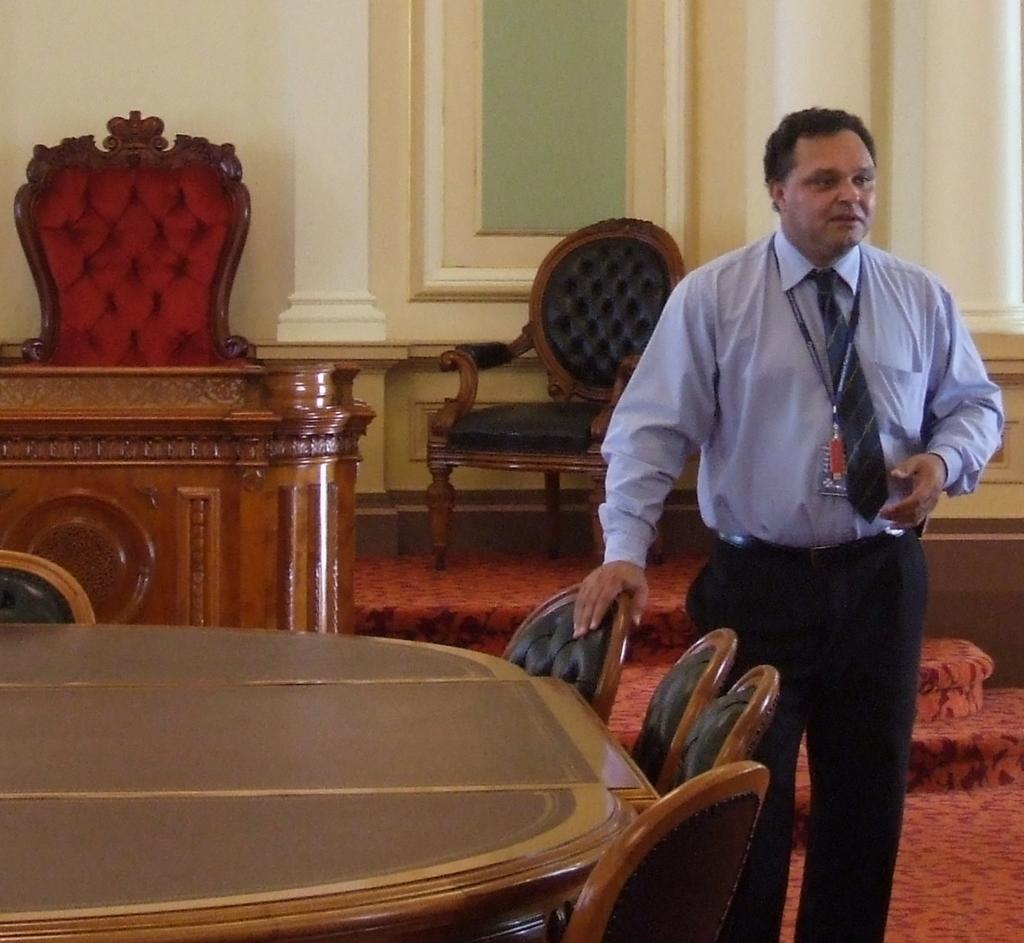What is the main subject of the image? There is a man standing in the image. Where is the man standing? The man is standing on the floor. What furniture is present in the image? There is a table and chairs in the image. What can be seen in the background of the image? There is a wall and a window in the background of the image. How many ducks are sitting on the chairs in the image? There are no ducks present in the image; it only features a man standing, a table, chairs, a wall, and a window. Is the man wearing a veil in the image? There is no mention of a veil or any head covering in the image; the man is simply standing. 